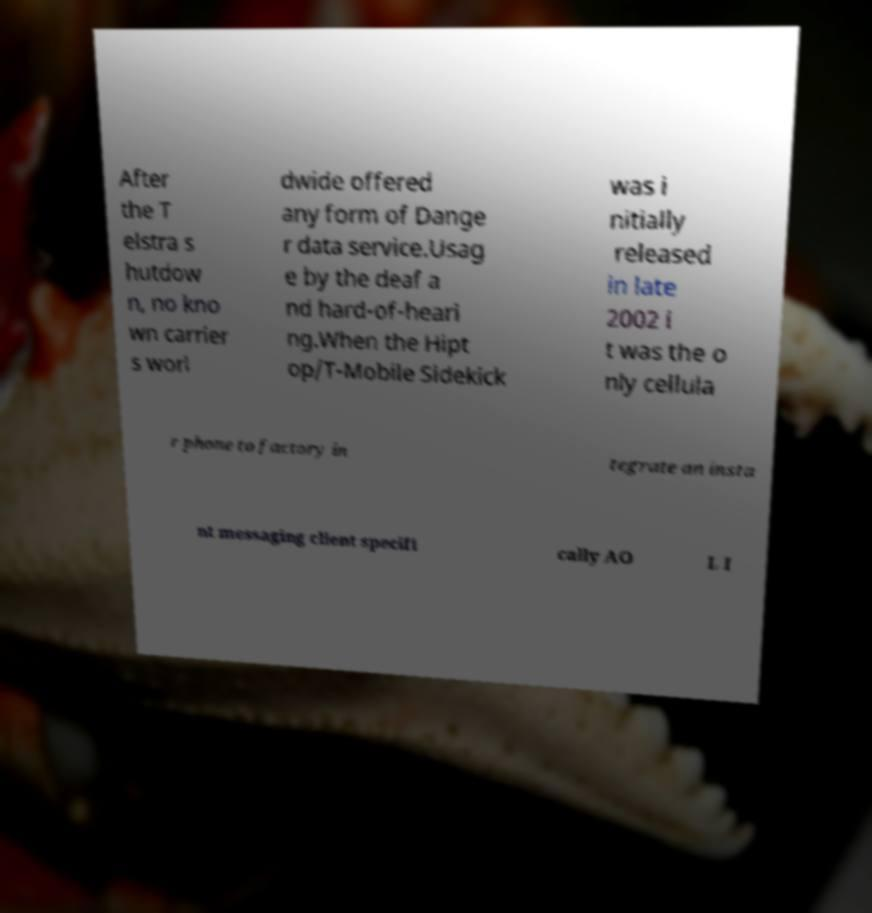Could you assist in decoding the text presented in this image and type it out clearly? After the T elstra s hutdow n, no kno wn carrier s worl dwide offered any form of Dange r data service.Usag e by the deaf a nd hard-of-heari ng.When the Hipt op/T-Mobile Sidekick was i nitially released in late 2002 i t was the o nly cellula r phone to factory in tegrate an insta nt messaging client specifi cally AO L I 